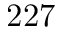<formula> <loc_0><loc_0><loc_500><loc_500>2 2 7</formula> 